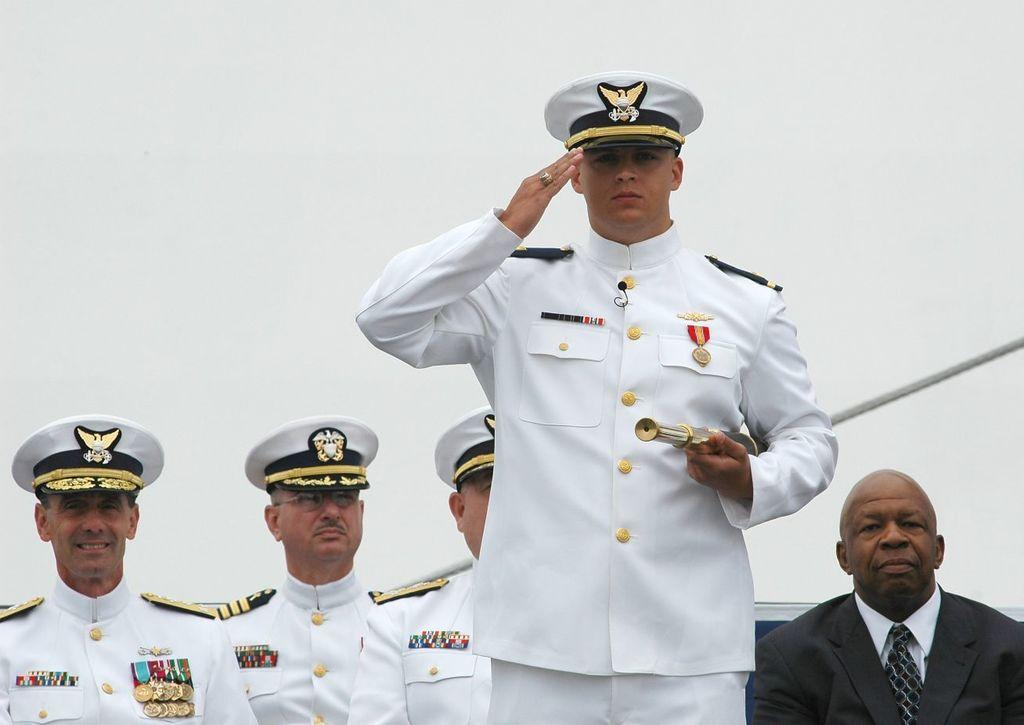What is the main subject of the image? The main subject of the image is a group of men. Can you describe the actions of one of the men in the image? One man is standing and holding a binocular. What object can be seen in the image that is typically used for tying or securing things? There is a rope visible in the image. What is visible in the background of the image? The sky is visible in the image. How would you describe the weather based on the appearance of the sky in the image? The sky appears to be cloudy in the image. How many cars are parked near the men in the image? There is no mention of cars in the image, so it is impossible to determine how many cars are parked near the men. Is there a wheel visible in the image? There is no wheel mentioned or visible in the image. 